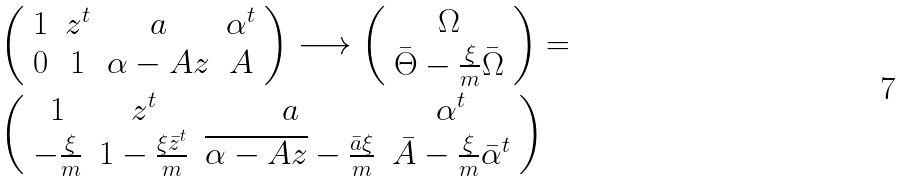Convert formula to latex. <formula><loc_0><loc_0><loc_500><loc_500>& \left ( \begin{array} { c c c c } 1 & z ^ { t } & a & \alpha ^ { t } \\ 0 & 1 & \alpha - A z & A \end{array} \right ) \longrightarrow \left ( \begin{array} { c } \Omega \\ \bar { \Theta } - \frac { \xi } { m } \bar { \Omega } \end{array} \right ) = \\ & \left ( \begin{array} { c c c c } 1 & z ^ { t } & a & \alpha ^ { t } \\ - \frac { \xi } { m } & 1 - \frac { \xi \bar { z } ^ { t } } { m } & \overline { \alpha - A z } - \frac { \bar { a } \xi } { m } & \bar { A } - \frac { \xi } { m } \bar { \alpha } ^ { t } \end{array} \right )</formula> 